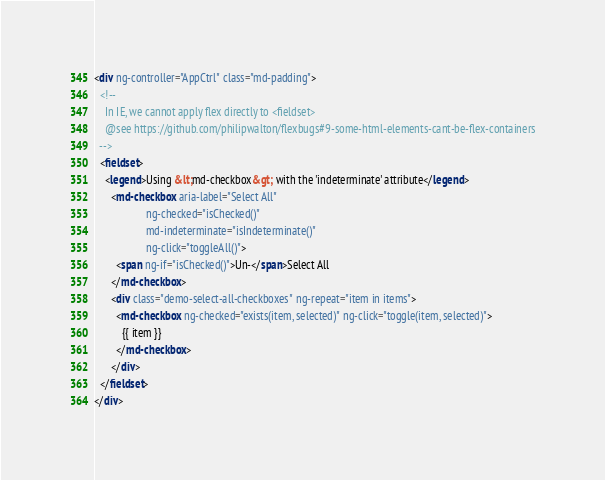Convert code to text. <code><loc_0><loc_0><loc_500><loc_500><_HTML_><div ng-controller="AppCtrl" class="md-padding">
  <!--
    In IE, we cannot apply flex directly to <fieldset>
    @see https://github.com/philipwalton/flexbugs#9-some-html-elements-cant-be-flex-containers
  -->
  <fieldset>
    <legend>Using &lt;md-checkbox&gt; with the 'indeterminate' attribute</legend>
      <md-checkbox aria-label="Select All"
                   ng-checked="isChecked()"
                   md-indeterminate="isIndeterminate()"
                   ng-click="toggleAll()">
        <span ng-if="isChecked()">Un-</span>Select All
      </md-checkbox>
      <div class="demo-select-all-checkboxes" ng-repeat="item in items">
        <md-checkbox ng-checked="exists(item, selected)" ng-click="toggle(item, selected)">
          {{ item }}
        </md-checkbox>
      </div>
  </fieldset>
</div>
</code> 